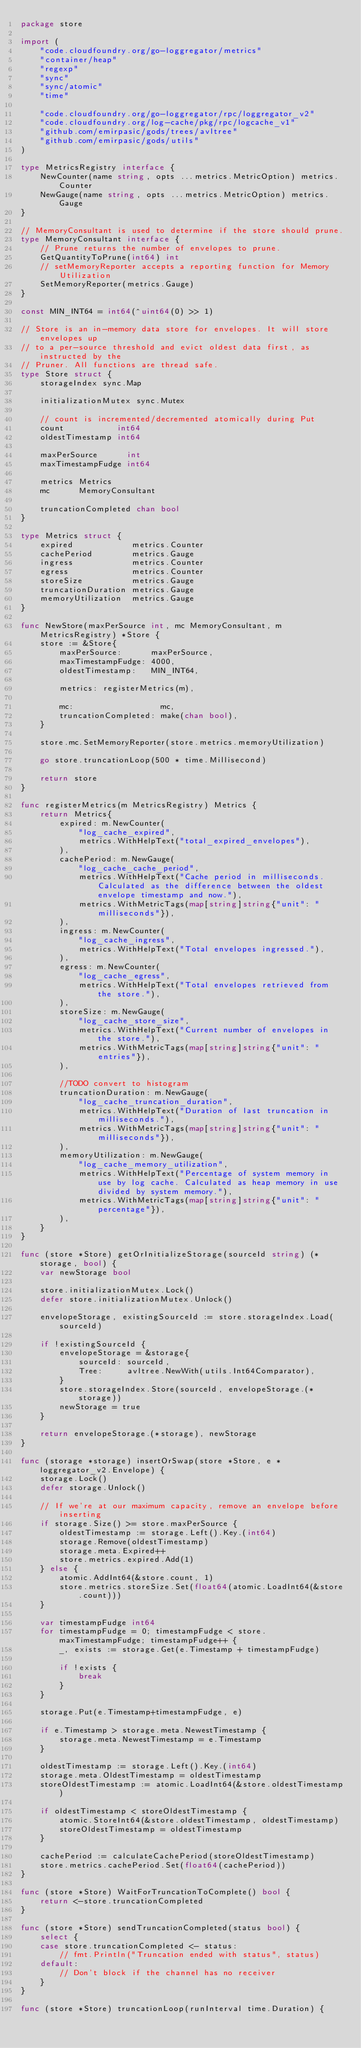Convert code to text. <code><loc_0><loc_0><loc_500><loc_500><_Go_>package store

import (
	"code.cloudfoundry.org/go-loggregator/metrics"
	"container/heap"
	"regexp"
	"sync"
	"sync/atomic"
	"time"

	"code.cloudfoundry.org/go-loggregator/rpc/loggregator_v2"
	"code.cloudfoundry.org/log-cache/pkg/rpc/logcache_v1"
	"github.com/emirpasic/gods/trees/avltree"
	"github.com/emirpasic/gods/utils"
)

type MetricsRegistry interface {
	NewCounter(name string, opts ...metrics.MetricOption) metrics.Counter
	NewGauge(name string, opts ...metrics.MetricOption) metrics.Gauge
}

// MemoryConsultant is used to determine if the store should prune.
type MemoryConsultant interface {
	// Prune returns the number of envelopes to prune.
	GetQuantityToPrune(int64) int
	// setMemoryReporter accepts a reporting function for Memory Utilization
	SetMemoryReporter(metrics.Gauge)
}

const MIN_INT64 = int64(^uint64(0) >> 1)

// Store is an in-memory data store for envelopes. It will store envelopes up
// to a per-source threshold and evict oldest data first, as instructed by the
// Pruner. All functions are thread safe.
type Store struct {
	storageIndex sync.Map

	initializationMutex sync.Mutex

	// count is incremented/decremented atomically during Put
	count           int64
	oldestTimestamp int64

	maxPerSource      int
	maxTimestampFudge int64

	metrics Metrics
	mc      MemoryConsultant

	truncationCompleted chan bool
}

type Metrics struct {
	expired            metrics.Counter
	cachePeriod        metrics.Gauge
	ingress            metrics.Counter
	egress             metrics.Counter
	storeSize          metrics.Gauge
	truncationDuration metrics.Gauge
	memoryUtilization  metrics.Gauge
}

func NewStore(maxPerSource int, mc MemoryConsultant, m MetricsRegistry) *Store {
	store := &Store{
		maxPerSource:      maxPerSource,
		maxTimestampFudge: 4000,
		oldestTimestamp:   MIN_INT64,

		metrics: registerMetrics(m),

		mc:                  mc,
		truncationCompleted: make(chan bool),
	}

	store.mc.SetMemoryReporter(store.metrics.memoryUtilization)

	go store.truncationLoop(500 * time.Millisecond)

	return store
}

func registerMetrics(m MetricsRegistry) Metrics {
	return Metrics{
		expired: m.NewCounter(
			"log_cache_expired",
			metrics.WithHelpText("total_expired_envelopes"),
		),
		cachePeriod: m.NewGauge(
			"log_cache_cache_period",
			metrics.WithHelpText("Cache period in milliseconds. Calculated as the difference between the oldest envelope timestamp and now."),
			metrics.WithMetricTags(map[string]string{"unit": "milliseconds"}),
		),
		ingress: m.NewCounter(
			"log_cache_ingress",
			metrics.WithHelpText("Total envelopes ingressed."),
		),
		egress: m.NewCounter(
			"log_cache_egress",
			metrics.WithHelpText("Total envelopes retrieved from the store."),
		),
		storeSize: m.NewGauge(
			"log_cache_store_size",
			metrics.WithHelpText("Current number of envelopes in the store."),
			metrics.WithMetricTags(map[string]string{"unit": "entries"}),
		),

		//TODO convert to histogram
		truncationDuration: m.NewGauge(
			"log_cache_truncation_duration",
			metrics.WithHelpText("Duration of last truncation in milliseconds."),
			metrics.WithMetricTags(map[string]string{"unit": "milliseconds"}),
		),
		memoryUtilization: m.NewGauge(
			"log_cache_memory_utilization",
			metrics.WithHelpText("Percentage of system memory in use by log cache. Calculated as heap memory in use divided by system memory."),
			metrics.WithMetricTags(map[string]string{"unit": "percentage"}),
		),
	}
}

func (store *Store) getOrInitializeStorage(sourceId string) (*storage, bool) {
	var newStorage bool

	store.initializationMutex.Lock()
	defer store.initializationMutex.Unlock()

	envelopeStorage, existingSourceId := store.storageIndex.Load(sourceId)

	if !existingSourceId {
		envelopeStorage = &storage{
			sourceId: sourceId,
			Tree:     avltree.NewWith(utils.Int64Comparator),
		}
		store.storageIndex.Store(sourceId, envelopeStorage.(*storage))
		newStorage = true
	}

	return envelopeStorage.(*storage), newStorage
}

func (storage *storage) insertOrSwap(store *Store, e *loggregator_v2.Envelope) {
	storage.Lock()
	defer storage.Unlock()

	// If we're at our maximum capacity, remove an envelope before inserting
	if storage.Size() >= store.maxPerSource {
		oldestTimestamp := storage.Left().Key.(int64)
		storage.Remove(oldestTimestamp)
		storage.meta.Expired++
		store.metrics.expired.Add(1)
	} else {
		atomic.AddInt64(&store.count, 1)
		store.metrics.storeSize.Set(float64(atomic.LoadInt64(&store.count)))
	}

	var timestampFudge int64
	for timestampFudge = 0; timestampFudge < store.maxTimestampFudge; timestampFudge++ {
		_, exists := storage.Get(e.Timestamp + timestampFudge)

		if !exists {
			break
		}
	}

	storage.Put(e.Timestamp+timestampFudge, e)

	if e.Timestamp > storage.meta.NewestTimestamp {
		storage.meta.NewestTimestamp = e.Timestamp
	}

	oldestTimestamp := storage.Left().Key.(int64)
	storage.meta.OldestTimestamp = oldestTimestamp
	storeOldestTimestamp := atomic.LoadInt64(&store.oldestTimestamp)

	if oldestTimestamp < storeOldestTimestamp {
		atomic.StoreInt64(&store.oldestTimestamp, oldestTimestamp)
		storeOldestTimestamp = oldestTimestamp
	}

	cachePeriod := calculateCachePeriod(storeOldestTimestamp)
	store.metrics.cachePeriod.Set(float64(cachePeriod))
}

func (store *Store) WaitForTruncationToComplete() bool {
	return <-store.truncationCompleted
}

func (store *Store) sendTruncationCompleted(status bool) {
	select {
	case store.truncationCompleted <- status:
		// fmt.Println("Truncation ended with status", status)
	default:
		// Don't block if the channel has no receiver
	}
}

func (store *Store) truncationLoop(runInterval time.Duration) {
</code> 